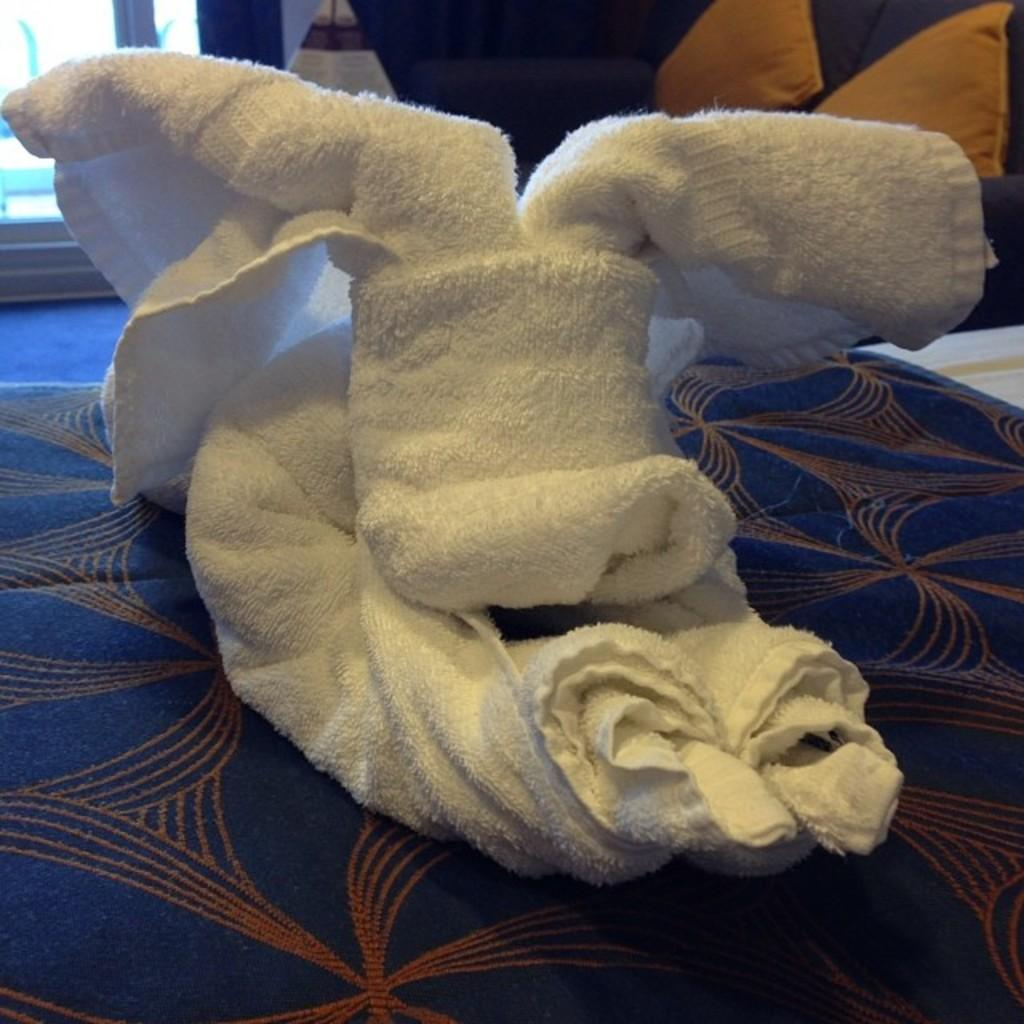What piece of furniture is present in the image? There is a bed in the image. What is placed on the bed? There is a white towel on the bed. What can be seen behind the towel? There are objects visible behind the towel. Reasoning: Let's think step by following the guidelines to produce the conversation. We start by identifying the main subject in the image, which is the bed. Then, we describe the white towel that is placed on the bed. Finally, we mention the objects visible behind the towel. Each question is designed to elicit a specific detail about the image that is known from the provided facts. Absurd Question/Answer: What is the name of the person who owns the kite in the image? There is no kite present in the image, so it is not possible to determine the name of the person who owns it. 